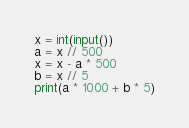Convert code to text. <code><loc_0><loc_0><loc_500><loc_500><_Python_>x = int(input())
a = x // 500
x = x - a * 500
b = x // 5
print(a * 1000 + b * 5)
</code> 